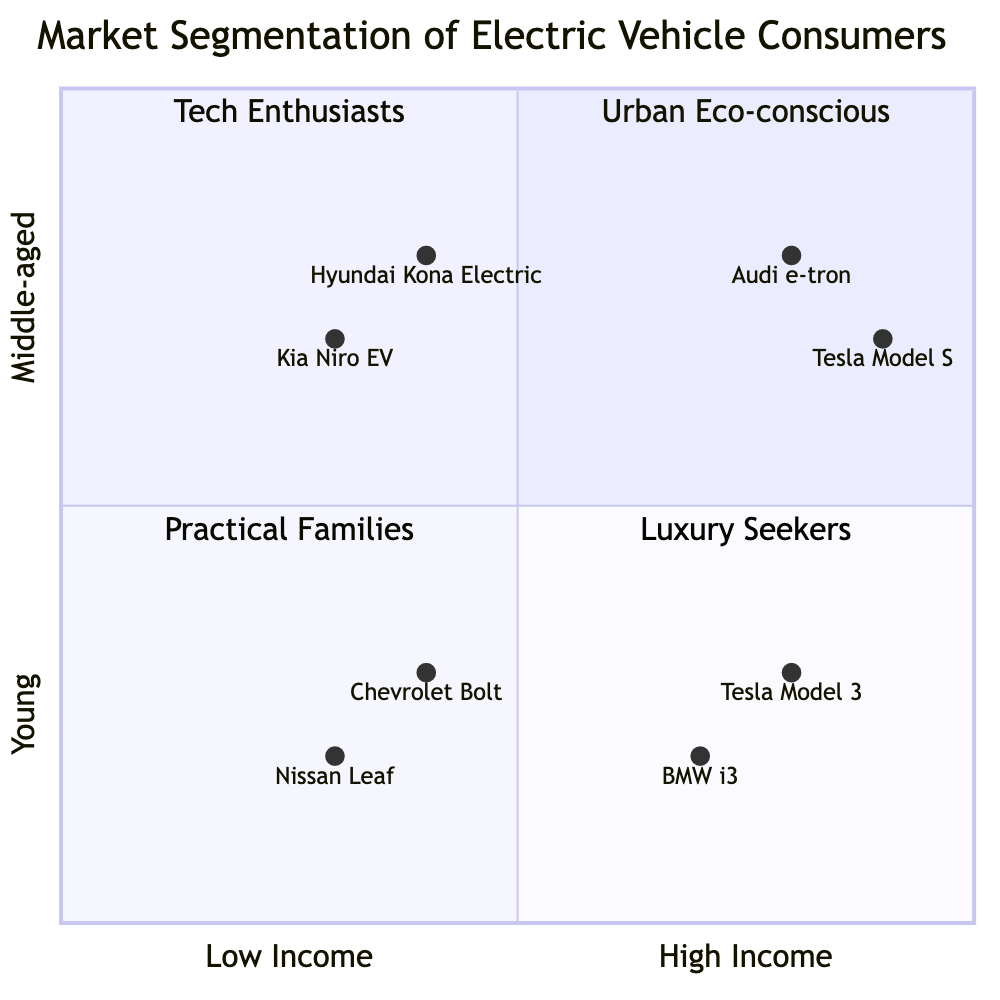What is the age bracket for tech enthusiasts? Based on the diagram, tech enthusiasts are located in the Top-Right quadrant, which indicates they are aged 18-29.
Answer: 18-29 Which brand is associated with urban eco-conscious consumers? In the Top-Left quadrant, which is for low-moderate income young consumers (18-29), the brands listed are Nissan Leaf and Chevrolet Bolt.
Answer: Nissan Leaf How many brands are targeted at family-oriented consumers? The Bottom-Left quadrant for low-moderate income middle-aged consumers (30-45) lists two brands: Kia Niro EV and Hyundai Kona Electric, making for a total of two brands.
Answer: 2 What characteristics describe luxury seekers? Luxury seekers are found in the Bottom-Right quadrant and exhibit characteristics of being established professionals, concerned about carbon footprint, seeking luxury and reliability, and interested in high-performance EVs.
Answer: Established professionals, concerned about carbon footprint Which brand has the highest income level segment in the diagram? Among the brands listed, Tesla Model S in the Bottom-Right quadrant targets high-income consumers and shows highest representation of luxury vehicles.
Answer: Tesla Model S How many segments focus on the 30-45 age bracket? The Bottom-Left and Bottom-Right quadrants each represent segments for consumers aged 30-45, resulting in two segments focusing on this age bracket.
Answer: 2 What is the purchasing power of consumers in the Top-Left quadrant? The Top-Left quadrant specifies that consumers have low-moderate income, indicating limited purchasing power.
Answer: Low-Moderate What is the driving factor for consumers in the Bottom-Left quadrant? Consumers in the Bottom-Left quadrant prioritize practicality and are looking for long-term savings, implying that these factors drive their purchasing decisions.
Answer: Practicality and long-term savings 